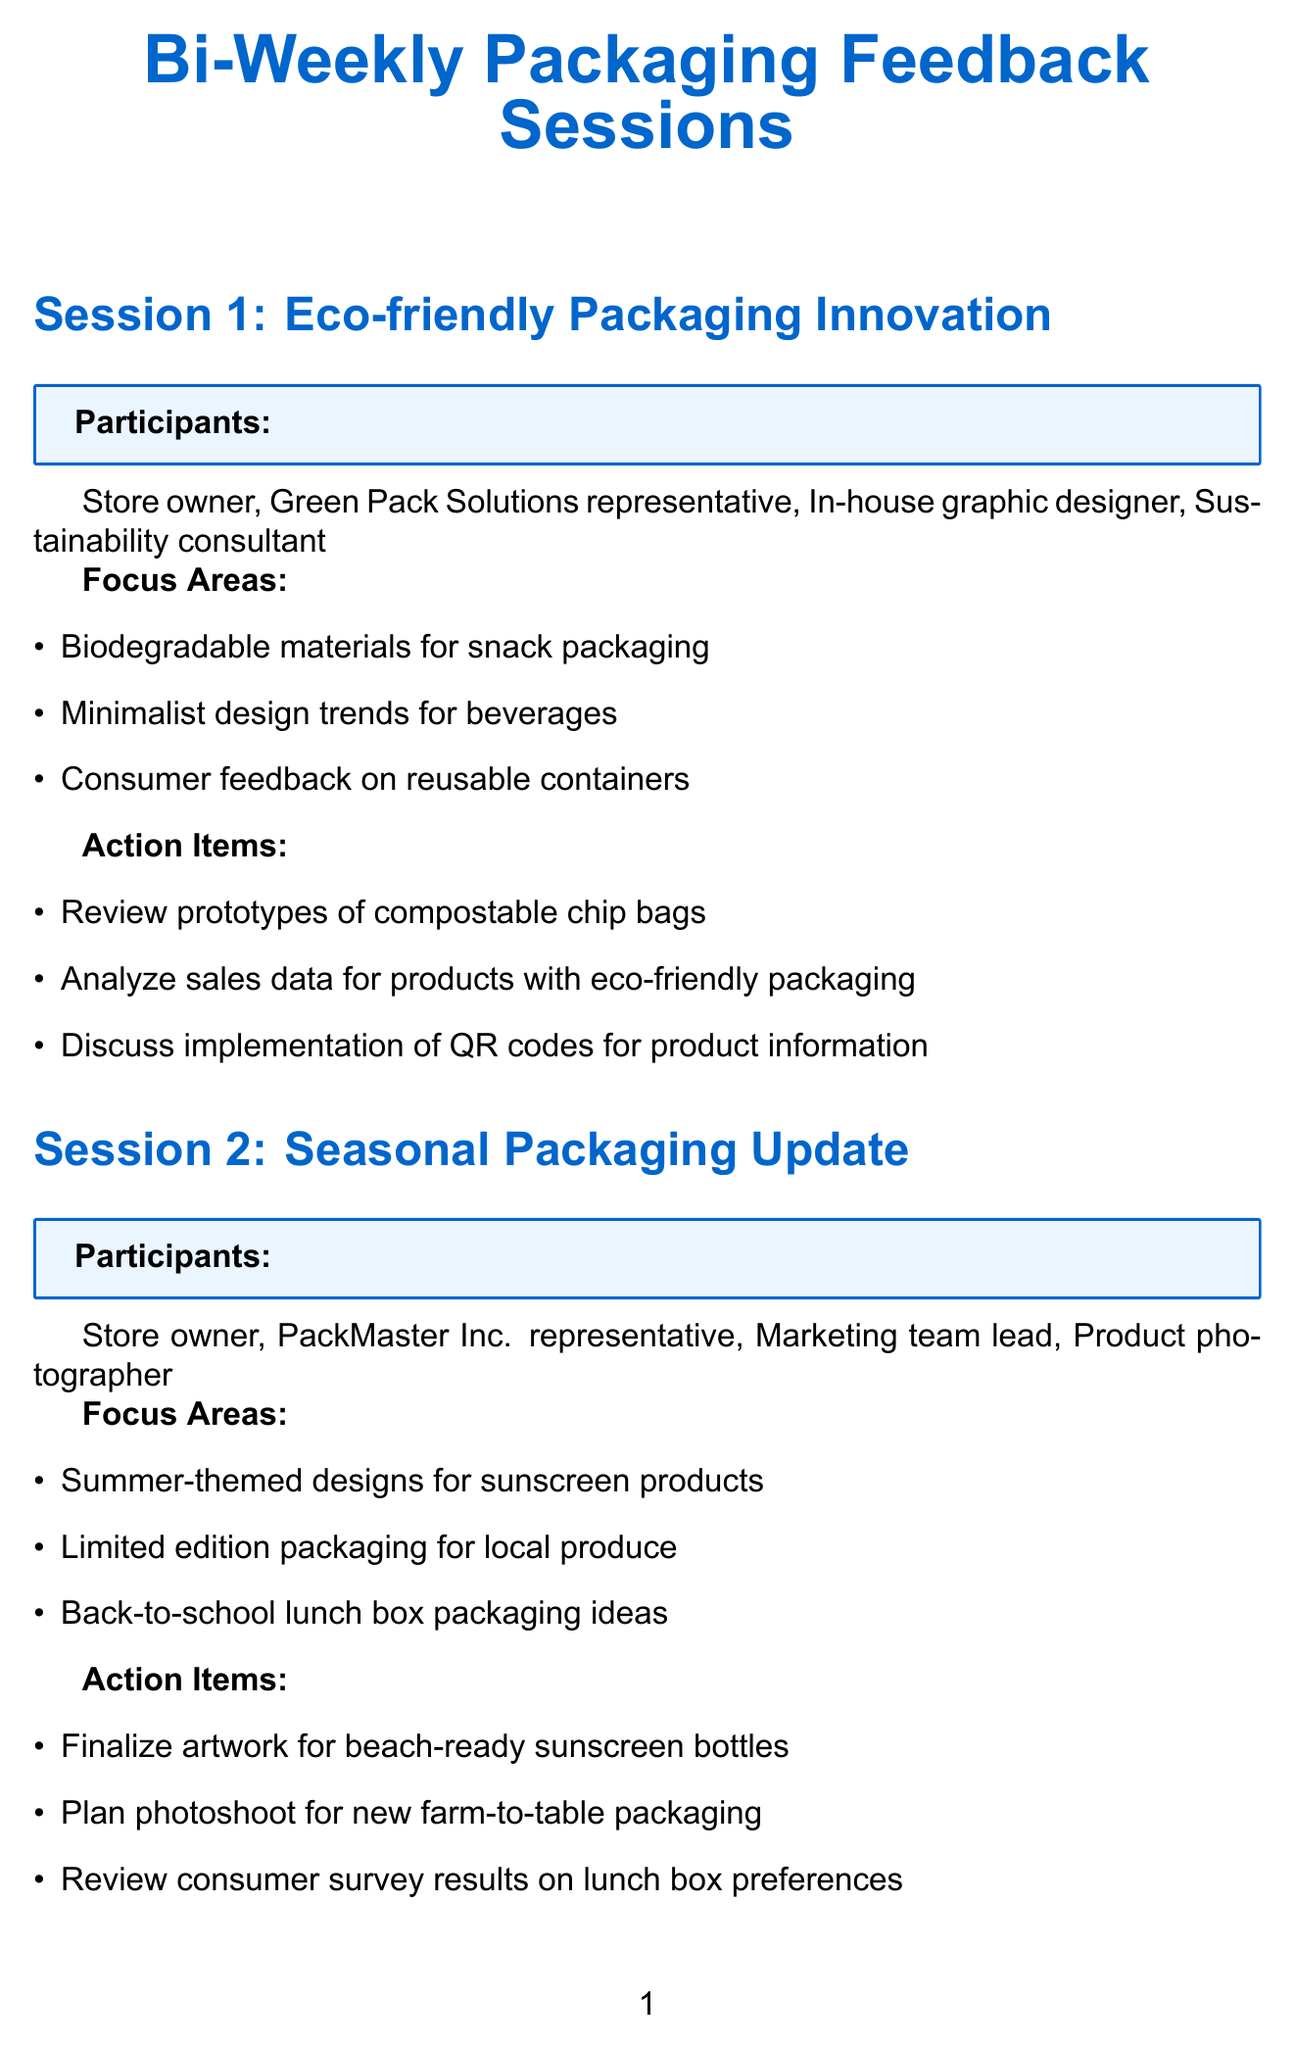What is the focus area of the first session? The first session focuses on biodegradable materials for snack packaging, minimalist design trends for beverages, and consumer feedback on reusable containers.
Answer: Biodegradable materials for snack packaging How many sessions are listed in the document? The document lists a total of five packaging feedback sessions.
Answer: 5 Who is the representative from TechPack Innovations? The name of the representative from TechPack Innovations is included in the document under the participants of the fourth session.
Answer: TechPack Innovations representative What is an action item from the second session? One of the action items from the second session is to finalize artwork for beach-ready sunscreen bottles.
Answer: Finalize artwork for beach-ready sunscreen bottles Which session includes a focus on augmented reality experiences? The session that includes a focus on augmented reality experiences is the fourth session titled "Innovative Packaging Technologies."
Answer: Innovative Packaging Technologies Who participates in the Brand Consistency Check session? The participants of the Brand Consistency Check session are listed in the document.
Answer: Store owner, BrandRight Agency representative, Quality control manager, Customer service team lead What is a focus area in the last session? The last session focuses on space-efficient designs for household cleaners, which is one of the listed focus areas.
Answer: Space-efficient designs for household cleaners What is one participant from the Eco-friendly Packaging Innovation session? The document specifies that the Store owner is one of the participants in the Eco-friendly Packaging Innovation session.
Answer: Store owner 